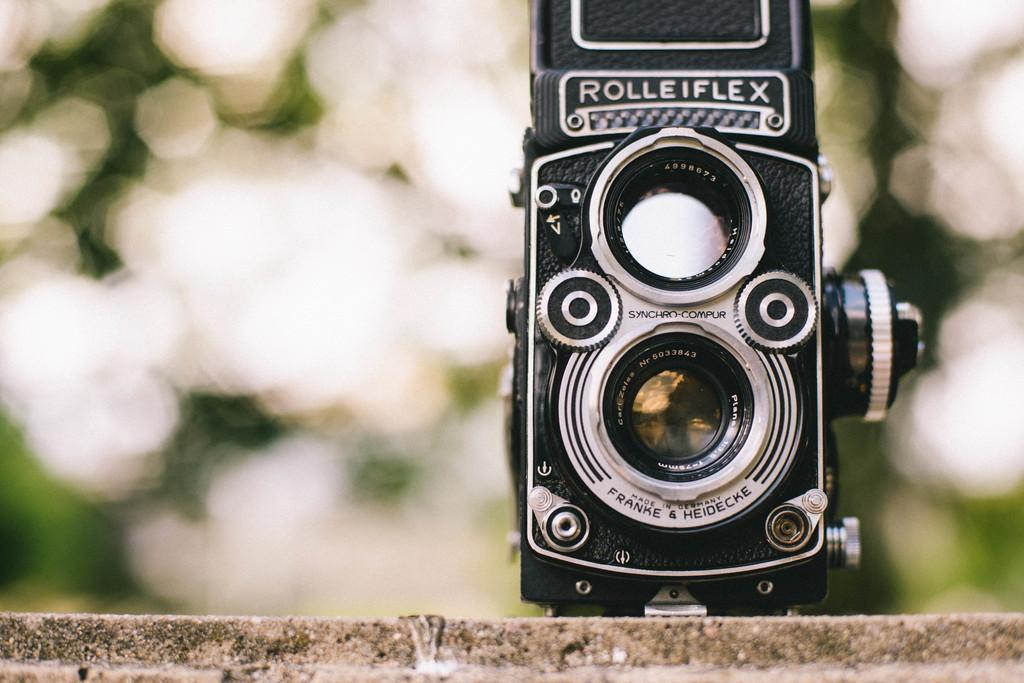What object is in the image? There is a camera in the image. Where is the camera located? The camera is placed on a wall. Is there any text on the camera? Yes, there is text on the camera. What type of sail can be seen on the chair in the image? There is no sail or chair present in the image; it only features a camera on a wall. 